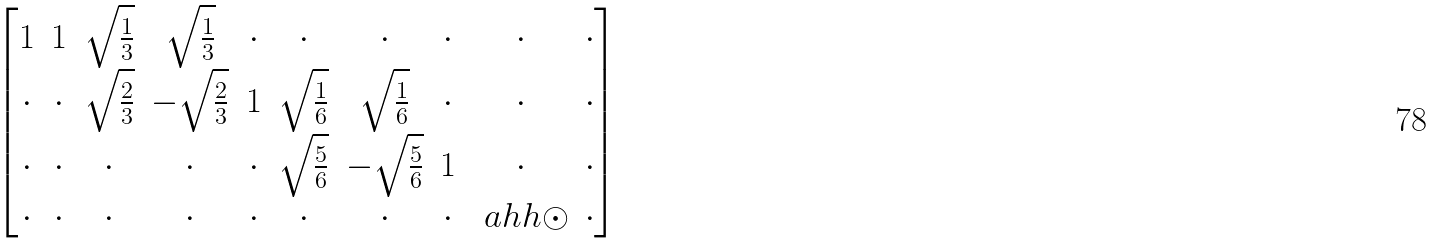<formula> <loc_0><loc_0><loc_500><loc_500>\begin{bmatrix} 1 & 1 & \sqrt { \frac { 1 } { 3 } } & \sqrt { \frac { 1 } { 3 } } & \cdot & \cdot & \cdot & \cdot & \cdot & \cdot \\ \cdot & \cdot & \sqrt { \frac { 2 } { 3 } } & - \sqrt { \frac { 2 } { 3 } } & 1 & \sqrt { \frac { 1 } { 6 } } & \sqrt { \frac { 1 } { 6 } } & \cdot & \cdot & \cdot \\ \cdot & \cdot & \cdot & \cdot & \cdot & \sqrt { \frac { 5 } { 6 } } & - \sqrt { \frac { 5 } { 6 } } & 1 & \cdot & \cdot \\ \cdot & \cdot & \cdot & \cdot & \cdot & \cdot & \cdot & \cdot & \ a h h { \odot } & \cdot \end{bmatrix}</formula> 